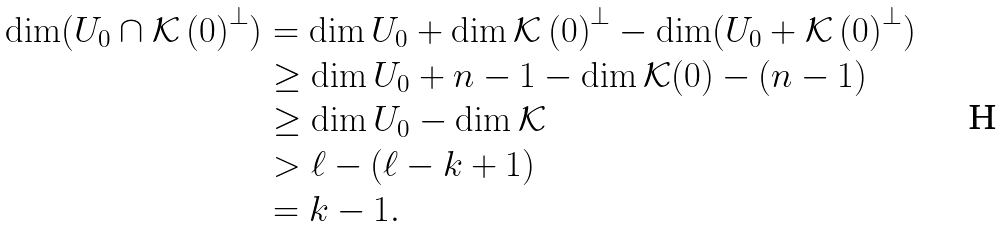Convert formula to latex. <formula><loc_0><loc_0><loc_500><loc_500>\dim ( U _ { 0 } \cap \mathcal { K } \left ( 0 \right ) ^ { \perp } ) & = \dim U _ { 0 } + \dim \mathcal { K } \left ( 0 \right ) ^ { \perp } - \dim ( U _ { 0 } + \mathcal { K } \left ( 0 \right ) ^ { \perp } ) \\ & \geq \dim U _ { 0 } + n - 1 - \dim \mathcal { K } ( 0 ) - \left ( n - 1 \right ) \\ & \geq \dim U _ { 0 } - \dim \mathcal { K } \\ & > \ell - \left ( \ell - k + 1 \right ) \\ & = k - 1 .</formula> 